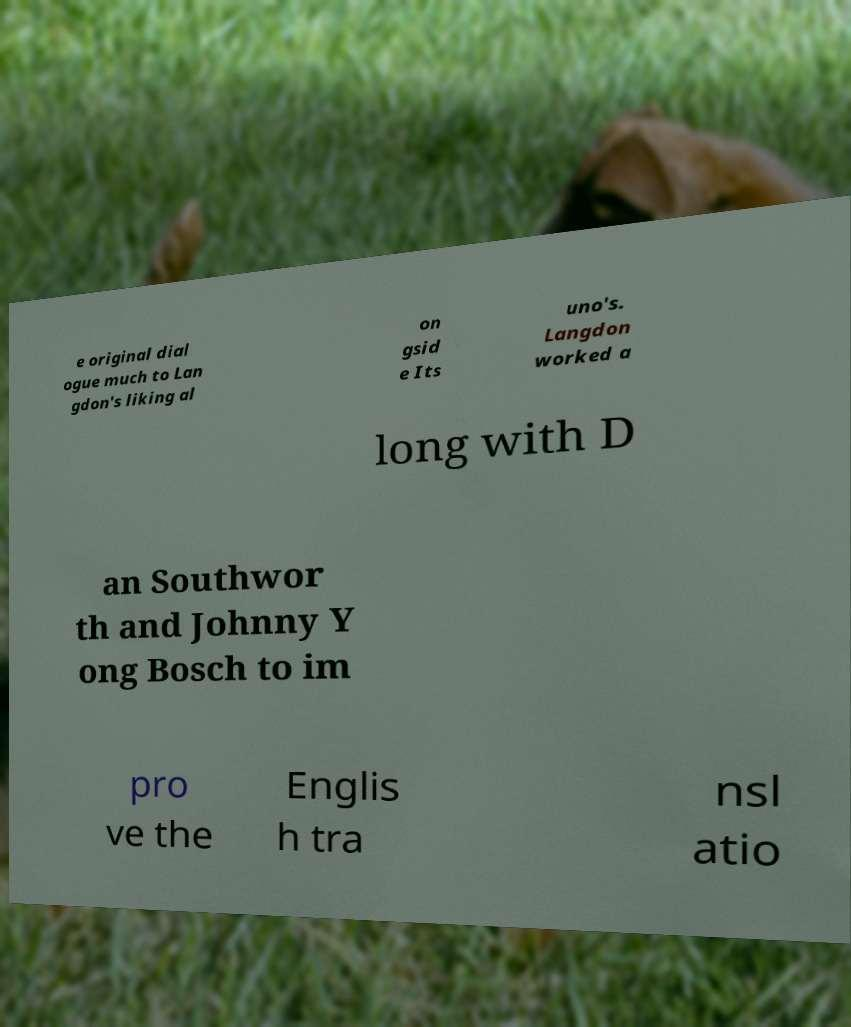What messages or text are displayed in this image? I need them in a readable, typed format. e original dial ogue much to Lan gdon's liking al on gsid e Its uno's. Langdon worked a long with D an Southwor th and Johnny Y ong Bosch to im pro ve the Englis h tra nsl atio 